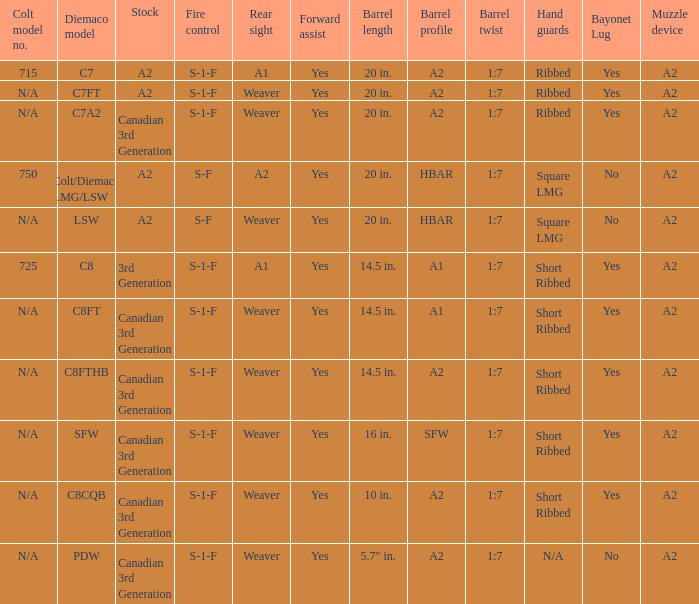Which barrel twist possesses a canadian 3rd generation stock and short ribbed hand guards? 1:7, 1:7, 1:7, 1:7. 